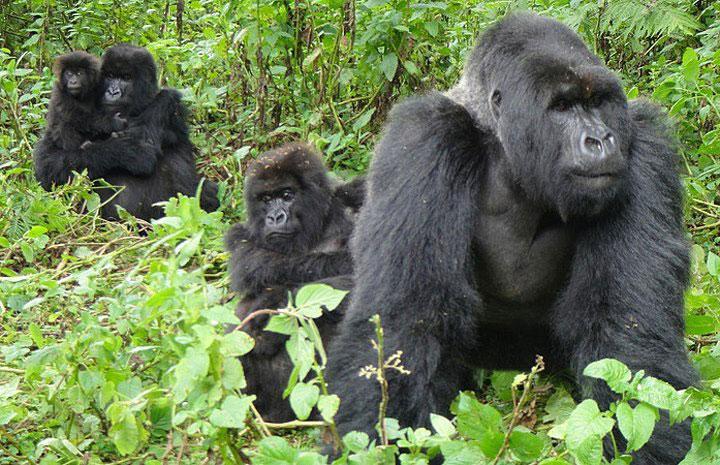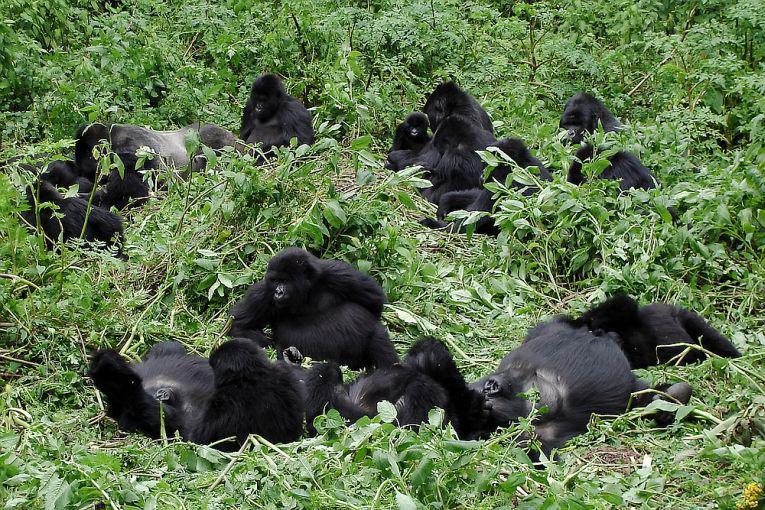The first image is the image on the left, the second image is the image on the right. Assess this claim about the two images: "The right image contains no more than two gorillas.". Correct or not? Answer yes or no. No. The first image is the image on the left, the second image is the image on the right. For the images shown, is this caption "In at least one image there is a baby gorilla trying to hold onto the back of a large gorilla." true? Answer yes or no. Yes. 